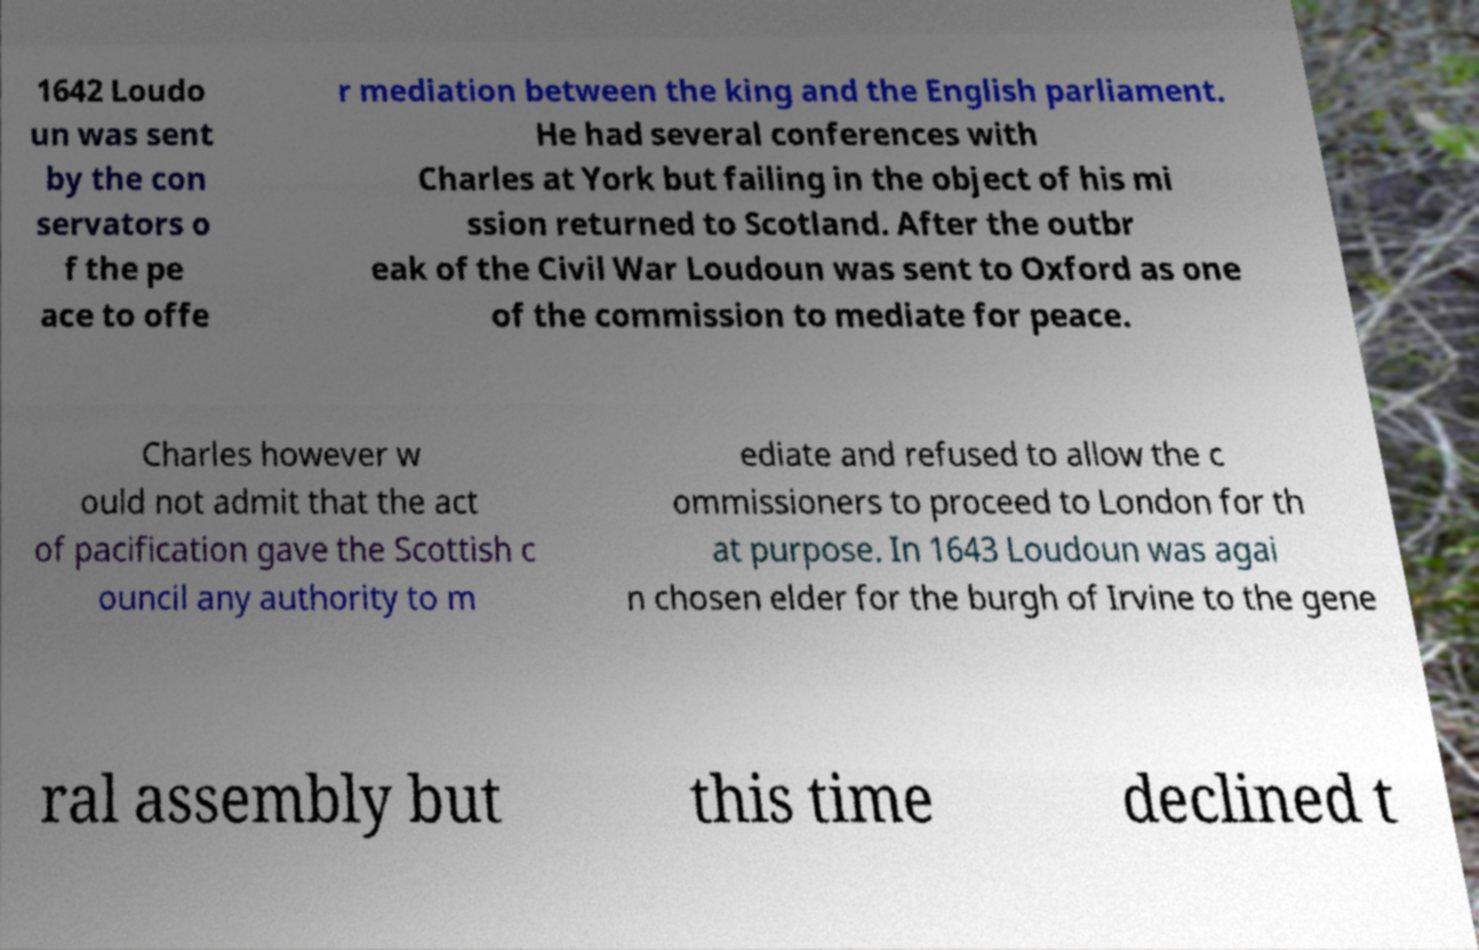Can you read and provide the text displayed in the image?This photo seems to have some interesting text. Can you extract and type it out for me? 1642 Loudo un was sent by the con servators o f the pe ace to offe r mediation between the king and the English parliament. He had several conferences with Charles at York but failing in the object of his mi ssion returned to Scotland. After the outbr eak of the Civil War Loudoun was sent to Oxford as one of the commission to mediate for peace. Charles however w ould not admit that the act of pacification gave the Scottish c ouncil any authority to m ediate and refused to allow the c ommissioners to proceed to London for th at purpose. In 1643 Loudoun was agai n chosen elder for the burgh of Irvine to the gene ral assembly but this time declined t 